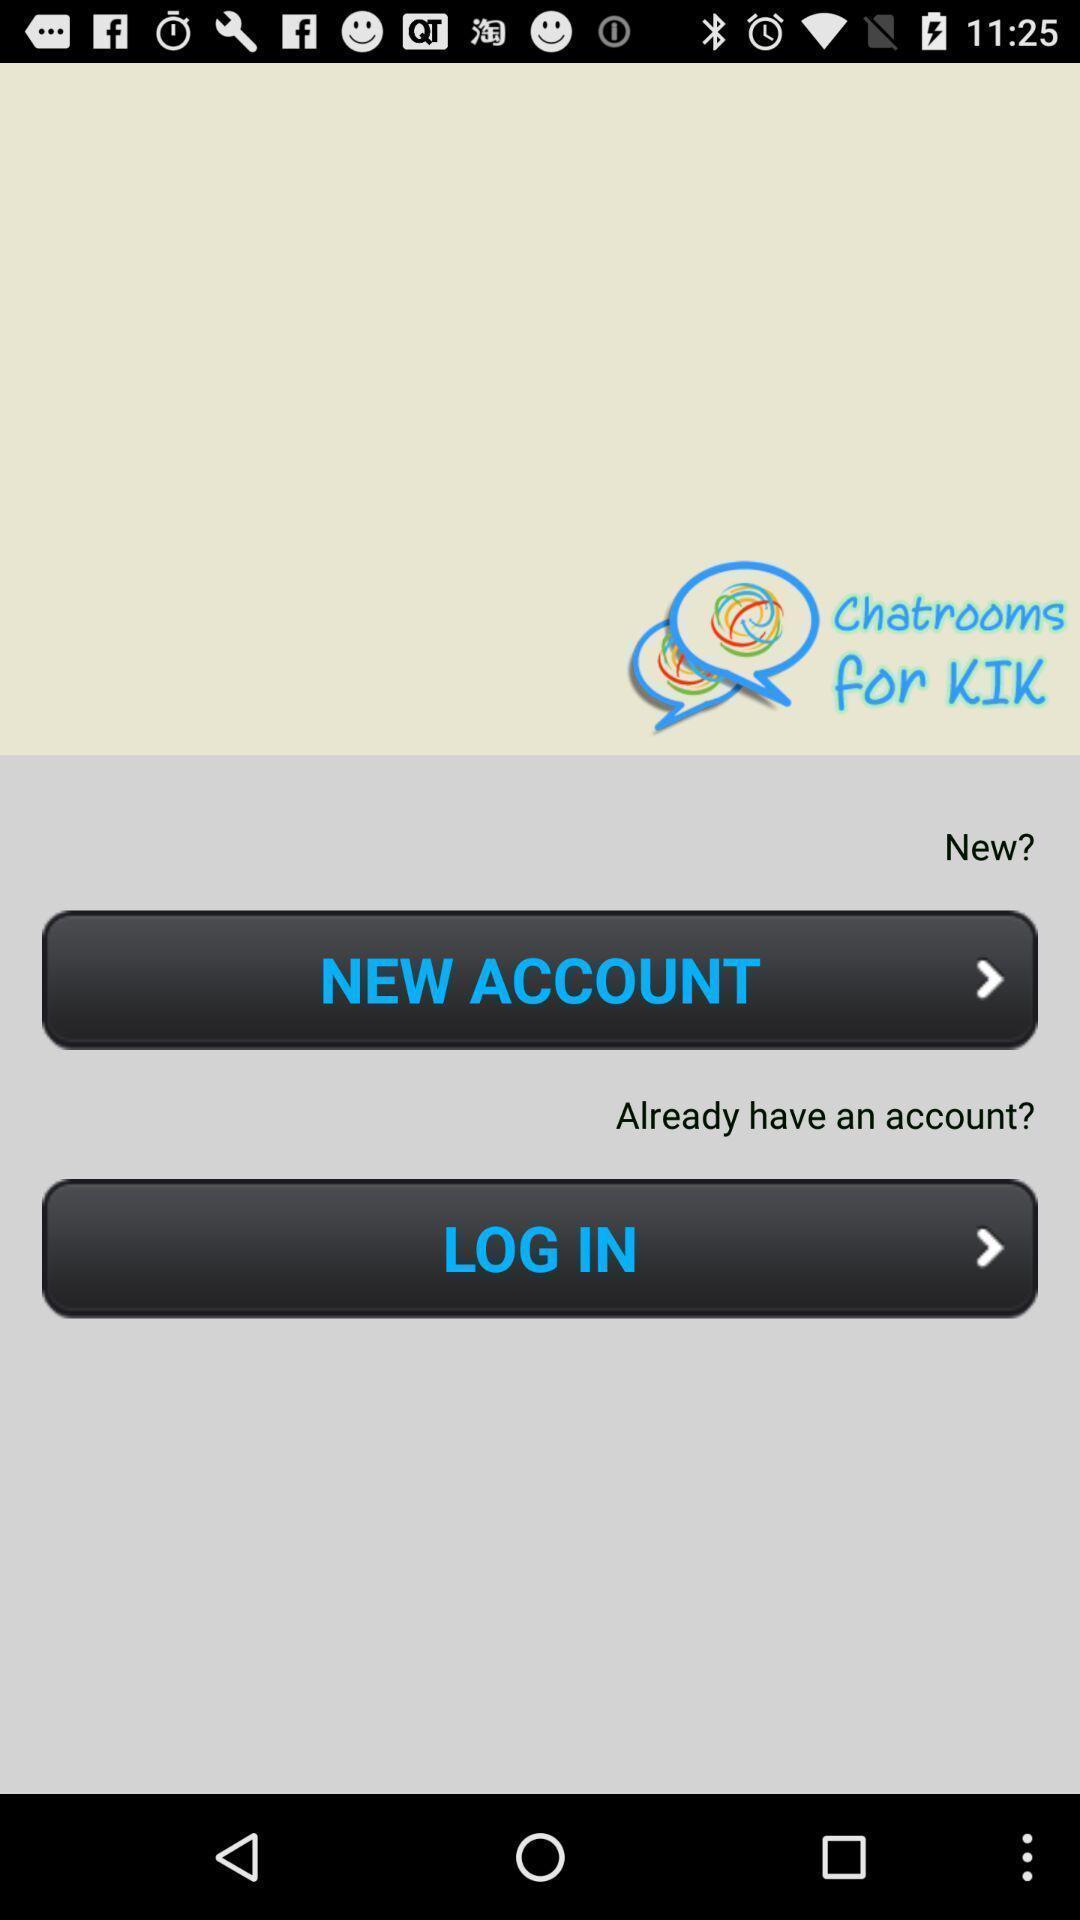Explain what's happening in this screen capture. Welcome page. 